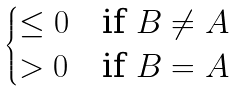<formula> <loc_0><loc_0><loc_500><loc_500>\begin{cases} \leq 0 & \text {if $B\neq A$} \\ > 0 & \text {if $B=A$} \end{cases}</formula> 